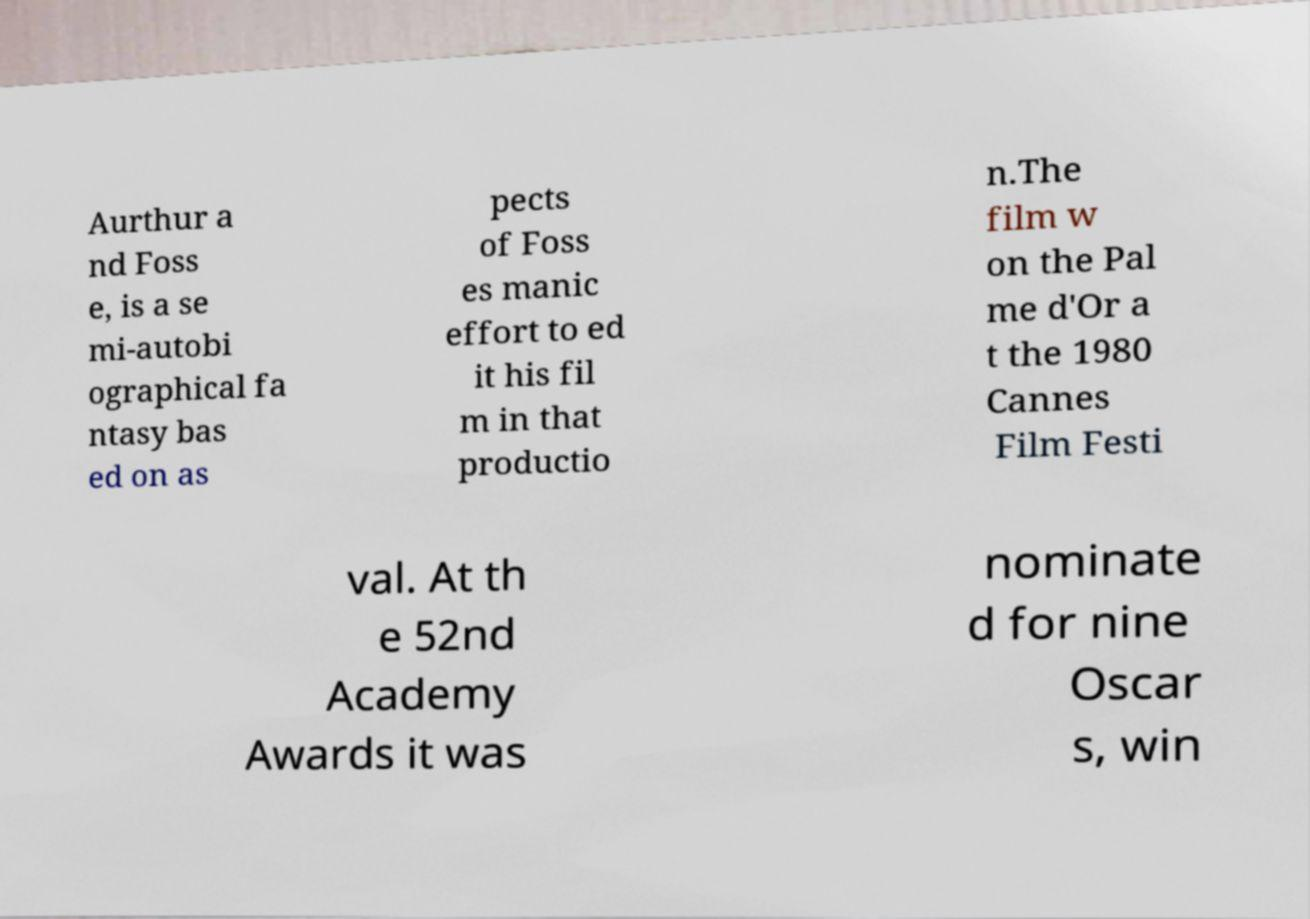Can you accurately transcribe the text from the provided image for me? Aurthur a nd Foss e, is a se mi-autobi ographical fa ntasy bas ed on as pects of Foss es manic effort to ed it his fil m in that productio n.The film w on the Pal me d'Or a t the 1980 Cannes Film Festi val. At th e 52nd Academy Awards it was nominate d for nine Oscar s, win 